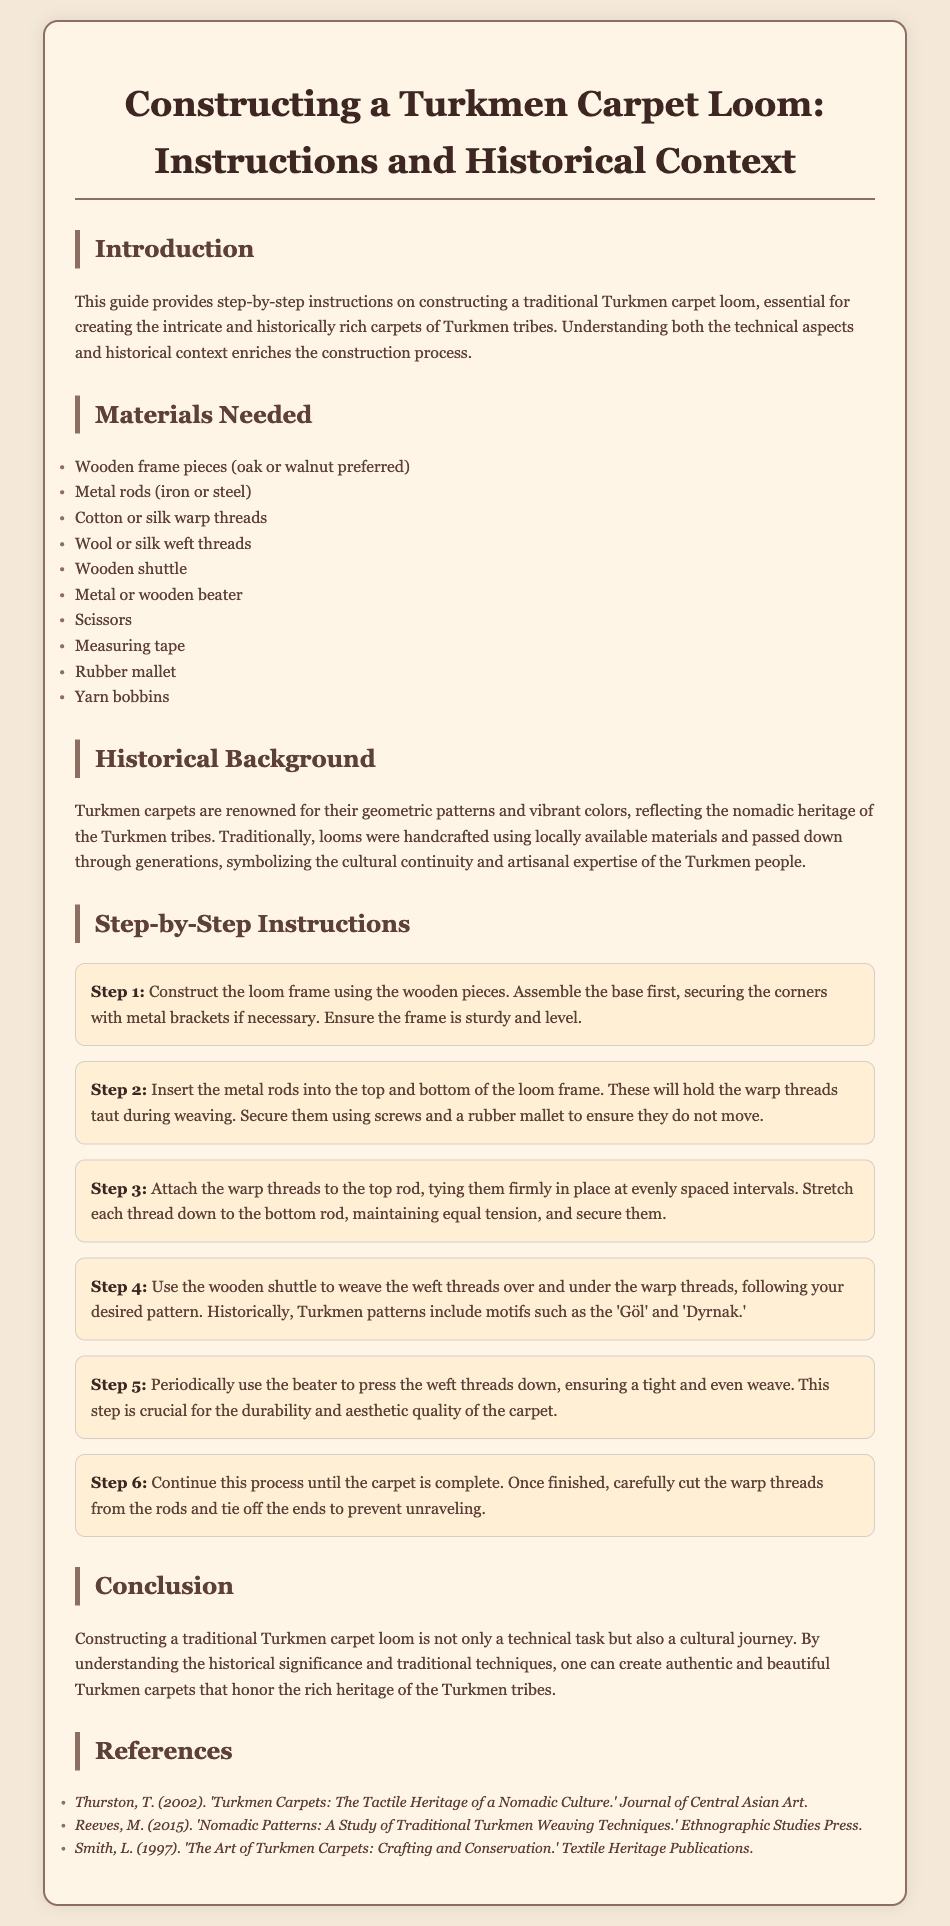What is the primary material for the loom frame? The document states that oak or walnut is preferred for the loom frame.
Answer: oak or walnut Name one type of thread needed for construction. The document lists cotton or silk as the warp threads needed for construction.
Answer: cotton or silk How many steps are outlined in the instructions? The document mentions six distinct steps for constructing the loom.
Answer: 6 What is the purpose of the metal rods in the loom? The metal rods are used to hold the warp threads taut during weaving.
Answer: hold the warp threads taut Which patterns are mentioned as historically significant in Turkmen carpets? The steps mention 'Göl' and 'Dyrnak' as examples of Turkmen patterns.
Answer: 'Göl' and 'Dyrnak' What tool is used to ensure a tight and even weave? The instructions specify using a beater to press the weft threads down.
Answer: beater Who authored the document referenced regarding Turkmen carpets' tactile heritage? The document attributes authorship of a relevant study to T. Thurston.
Answer: T. Thurston What is the color of the body text in the document? The body text color is indicated as #5d4037 in the styling section of the document.
Answer: #5d4037 